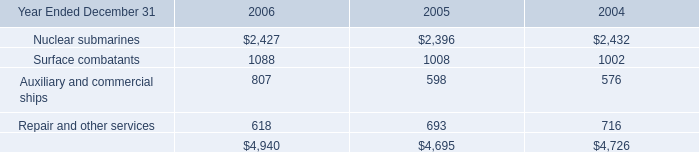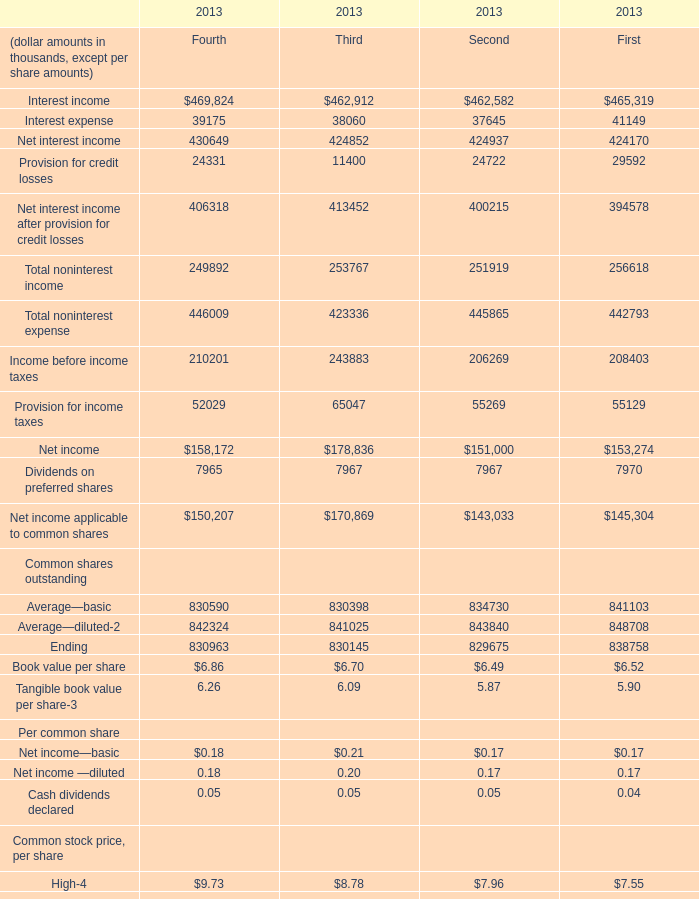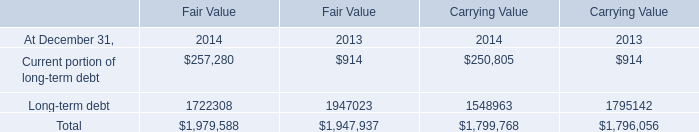what's the total amount of Surface combatants of 2006, and Interest income of 2013 Second ? 
Computations: (1088.0 + 462582.0)
Answer: 463670.0. 